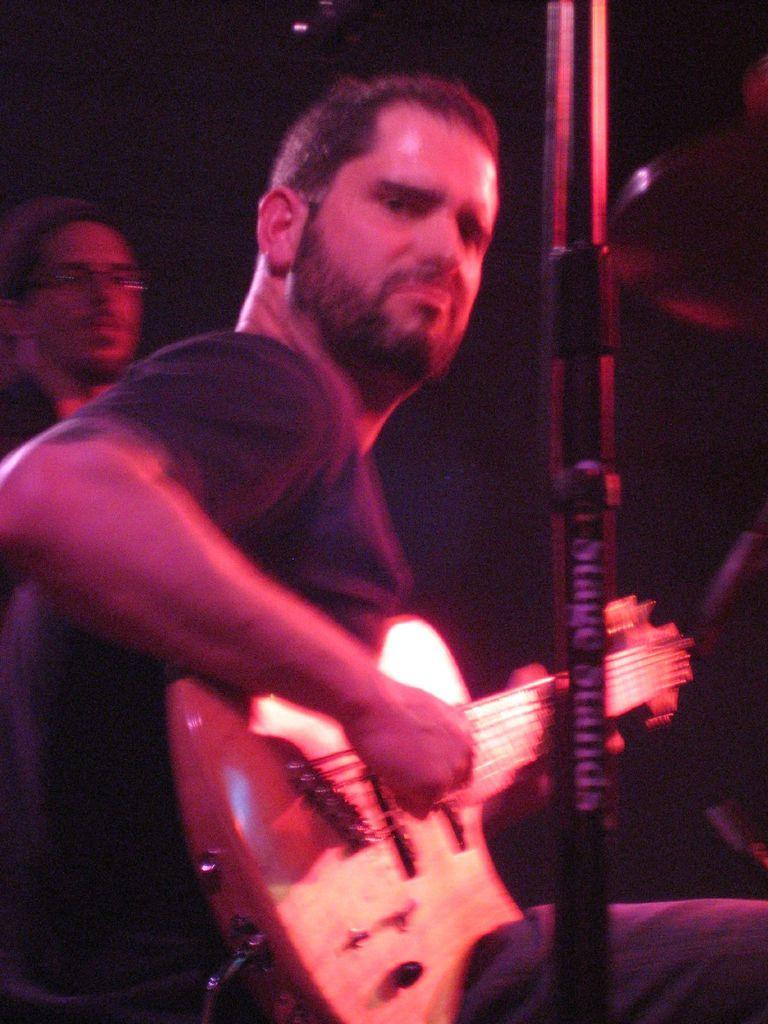What is the person in the image doing? The person is sitting and playing a guitar in the image. Can you describe the other person in the image? There is another person standing behind the person playing the guitar. What type of cherries is the person playing the guitar eating in the image? There are no cherries present in the image, and the person playing the guitar is not eating anything. 